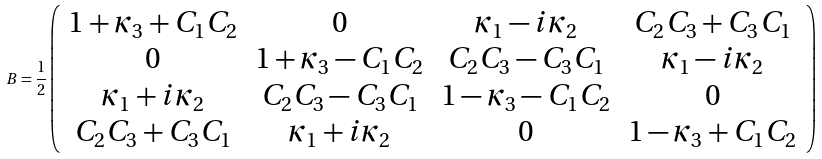Convert formula to latex. <formula><loc_0><loc_0><loc_500><loc_500>B = \frac { 1 } { 2 } \left ( \begin{array} { c c c c } 1 + \kappa _ { 3 } + C _ { 1 } C _ { 2 } & 0 & \kappa _ { 1 } - i \kappa _ { 2 } & C _ { 2 } C _ { 3 } + C _ { 3 } C _ { 1 } \\ 0 & 1 + \kappa _ { 3 } - C _ { 1 } C _ { 2 } & C _ { 2 } C _ { 3 } - C _ { 3 } C _ { 1 } & \kappa _ { 1 } - i \kappa _ { 2 } \\ \kappa _ { 1 } + i \kappa _ { 2 } & C _ { 2 } C _ { 3 } - C _ { 3 } C _ { 1 } & 1 - \kappa _ { 3 } - C _ { 1 } C _ { 2 } & 0 \\ C _ { 2 } C _ { 3 } + C _ { 3 } C _ { 1 } & \kappa _ { 1 } + i \kappa _ { 2 } & 0 & 1 - \kappa _ { 3 } + C _ { 1 } C _ { 2 } \end{array} \right )</formula> 